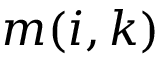Convert formula to latex. <formula><loc_0><loc_0><loc_500><loc_500>m ( i , k )</formula> 